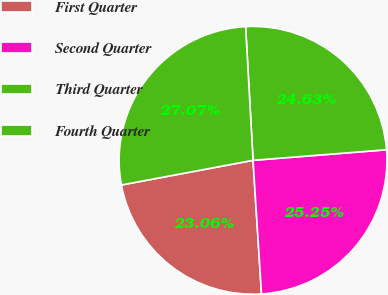Convert chart. <chart><loc_0><loc_0><loc_500><loc_500><pie_chart><fcel>First Quarter<fcel>Second Quarter<fcel>Third Quarter<fcel>Fourth Quarter<nl><fcel>23.06%<fcel>25.25%<fcel>24.63%<fcel>27.07%<nl></chart> 